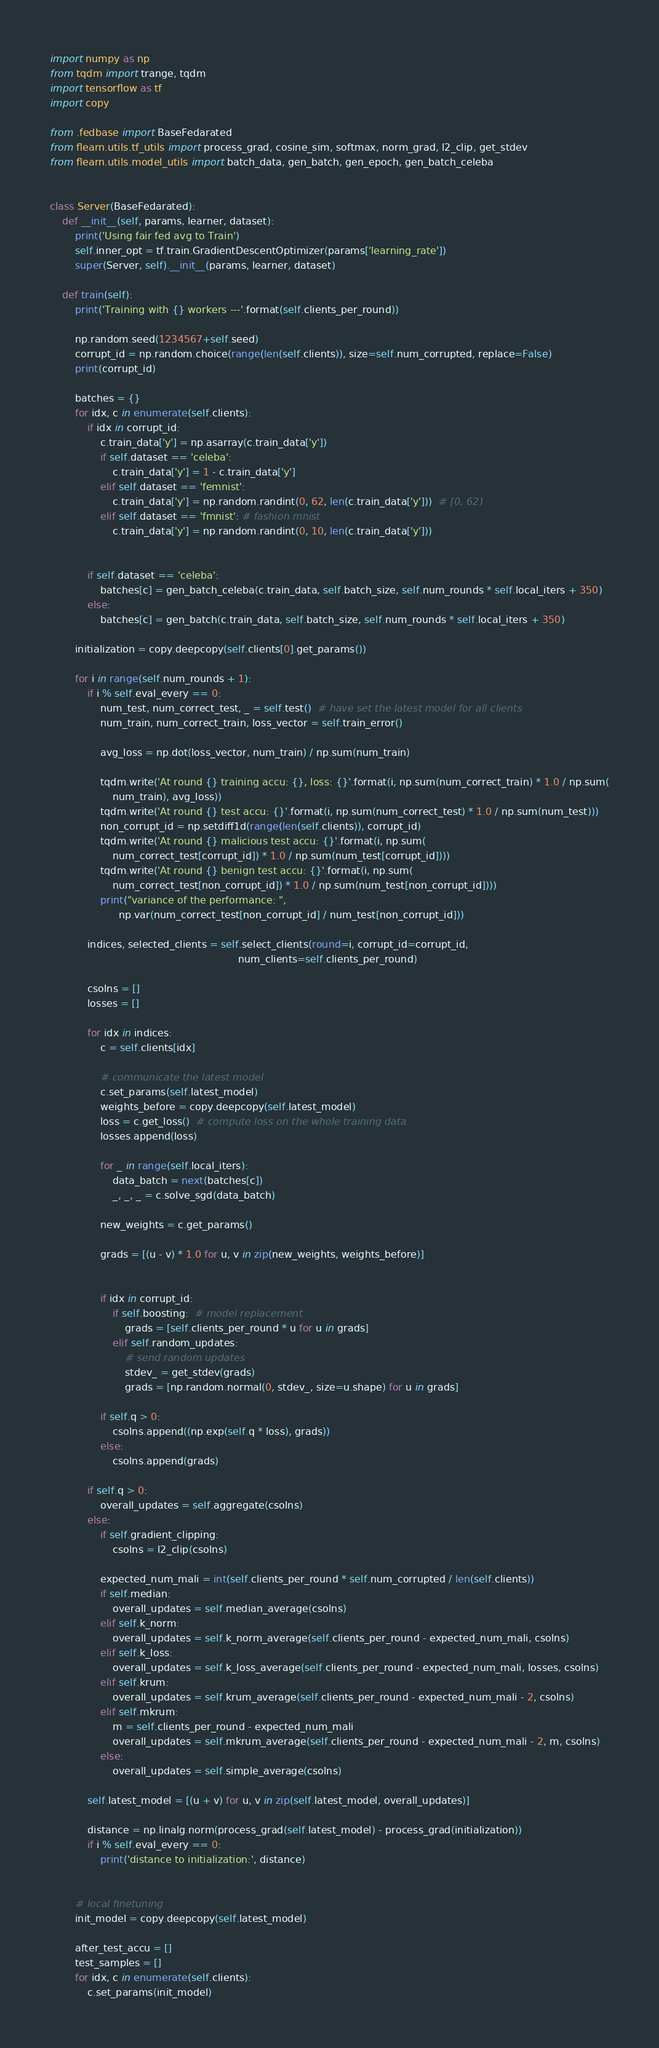Convert code to text. <code><loc_0><loc_0><loc_500><loc_500><_Python_>import numpy as np
from tqdm import trange, tqdm
import tensorflow as tf
import copy

from .fedbase import BaseFedarated
from flearn.utils.tf_utils import process_grad, cosine_sim, softmax, norm_grad, l2_clip, get_stdev
from flearn.utils.model_utils import batch_data, gen_batch, gen_epoch, gen_batch_celeba


class Server(BaseFedarated):
    def __init__(self, params, learner, dataset):
        print('Using fair fed avg to Train')
        self.inner_opt = tf.train.GradientDescentOptimizer(params['learning_rate'])
        super(Server, self).__init__(params, learner, dataset)

    def train(self):
        print('Training with {} workers ---'.format(self.clients_per_round))

        np.random.seed(1234567+self.seed)
        corrupt_id = np.random.choice(range(len(self.clients)), size=self.num_corrupted, replace=False)
        print(corrupt_id)

        batches = {}
        for idx, c in enumerate(self.clients):
            if idx in corrupt_id:
                c.train_data['y'] = np.asarray(c.train_data['y'])
                if self.dataset == 'celeba':
                    c.train_data['y'] = 1 - c.train_data['y']
                elif self.dataset == 'femnist':
                    c.train_data['y'] = np.random.randint(0, 62, len(c.train_data['y']))  # [0, 62)
                elif self.dataset == 'fmnist': # fashion mnist
                    c.train_data['y'] = np.random.randint(0, 10, len(c.train_data['y']))


            if self.dataset == 'celeba':
                batches[c] = gen_batch_celeba(c.train_data, self.batch_size, self.num_rounds * self.local_iters + 350)
            else:
                batches[c] = gen_batch(c.train_data, self.batch_size, self.num_rounds * self.local_iters + 350)

        initialization = copy.deepcopy(self.clients[0].get_params())

        for i in range(self.num_rounds + 1):
            if i % self.eval_every == 0:
                num_test, num_correct_test, _ = self.test()  # have set the latest model for all clients
                num_train, num_correct_train, loss_vector = self.train_error()

                avg_loss = np.dot(loss_vector, num_train) / np.sum(num_train)

                tqdm.write('At round {} training accu: {}, loss: {}'.format(i, np.sum(num_correct_train) * 1.0 / np.sum(
                    num_train), avg_loss))
                tqdm.write('At round {} test accu: {}'.format(i, np.sum(num_correct_test) * 1.0 / np.sum(num_test)))
                non_corrupt_id = np.setdiff1d(range(len(self.clients)), corrupt_id)
                tqdm.write('At round {} malicious test accu: {}'.format(i, np.sum(
                    num_correct_test[corrupt_id]) * 1.0 / np.sum(num_test[corrupt_id])))
                tqdm.write('At round {} benign test accu: {}'.format(i, np.sum(
                    num_correct_test[non_corrupt_id]) * 1.0 / np.sum(num_test[non_corrupt_id])))
                print("variance of the performance: ",
                      np.var(num_correct_test[non_corrupt_id] / num_test[non_corrupt_id]))

            indices, selected_clients = self.select_clients(round=i, corrupt_id=corrupt_id,
                                                            num_clients=self.clients_per_round)

            csolns = []
            losses = []

            for idx in indices:
                c = self.clients[idx]

                # communicate the latest model
                c.set_params(self.latest_model)
                weights_before = copy.deepcopy(self.latest_model)
                loss = c.get_loss()  # compute loss on the whole training data
                losses.append(loss)

                for _ in range(self.local_iters):
                    data_batch = next(batches[c])
                    _, _, _ = c.solve_sgd(data_batch)

                new_weights = c.get_params()

                grads = [(u - v) * 1.0 for u, v in zip(new_weights, weights_before)]


                if idx in corrupt_id:
                    if self.boosting:  # model replacement
                        grads = [self.clients_per_round * u for u in grads]
                    elif self.random_updates:
                        # send random updates
                        stdev_ = get_stdev(grads)
                        grads = [np.random.normal(0, stdev_, size=u.shape) for u in grads]

                if self.q > 0:
                    csolns.append((np.exp(self.q * loss), grads))
                else:
                    csolns.append(grads)

            if self.q > 0:
                overall_updates = self.aggregate(csolns)
            else:
                if self.gradient_clipping:
                    csolns = l2_clip(csolns)

                expected_num_mali = int(self.clients_per_round * self.num_corrupted / len(self.clients))
                if self.median:
                    overall_updates = self.median_average(csolns)
                elif self.k_norm:
                    overall_updates = self.k_norm_average(self.clients_per_round - expected_num_mali, csolns)
                elif self.k_loss:
                    overall_updates = self.k_loss_average(self.clients_per_round - expected_num_mali, losses, csolns)
                elif self.krum:
                    overall_updates = self.krum_average(self.clients_per_round - expected_num_mali - 2, csolns)
                elif self.mkrum:
                    m = self.clients_per_round - expected_num_mali
                    overall_updates = self.mkrum_average(self.clients_per_round - expected_num_mali - 2, m, csolns)
                else:
                    overall_updates = self.simple_average(csolns)

            self.latest_model = [(u + v) for u, v in zip(self.latest_model, overall_updates)]

            distance = np.linalg.norm(process_grad(self.latest_model) - process_grad(initialization))
            if i % self.eval_every == 0:
                print('distance to initialization:', distance)


        # local finetuning
        init_model = copy.deepcopy(self.latest_model)

        after_test_accu = []
        test_samples = []
        for idx, c in enumerate(self.clients):
            c.set_params(init_model)</code> 